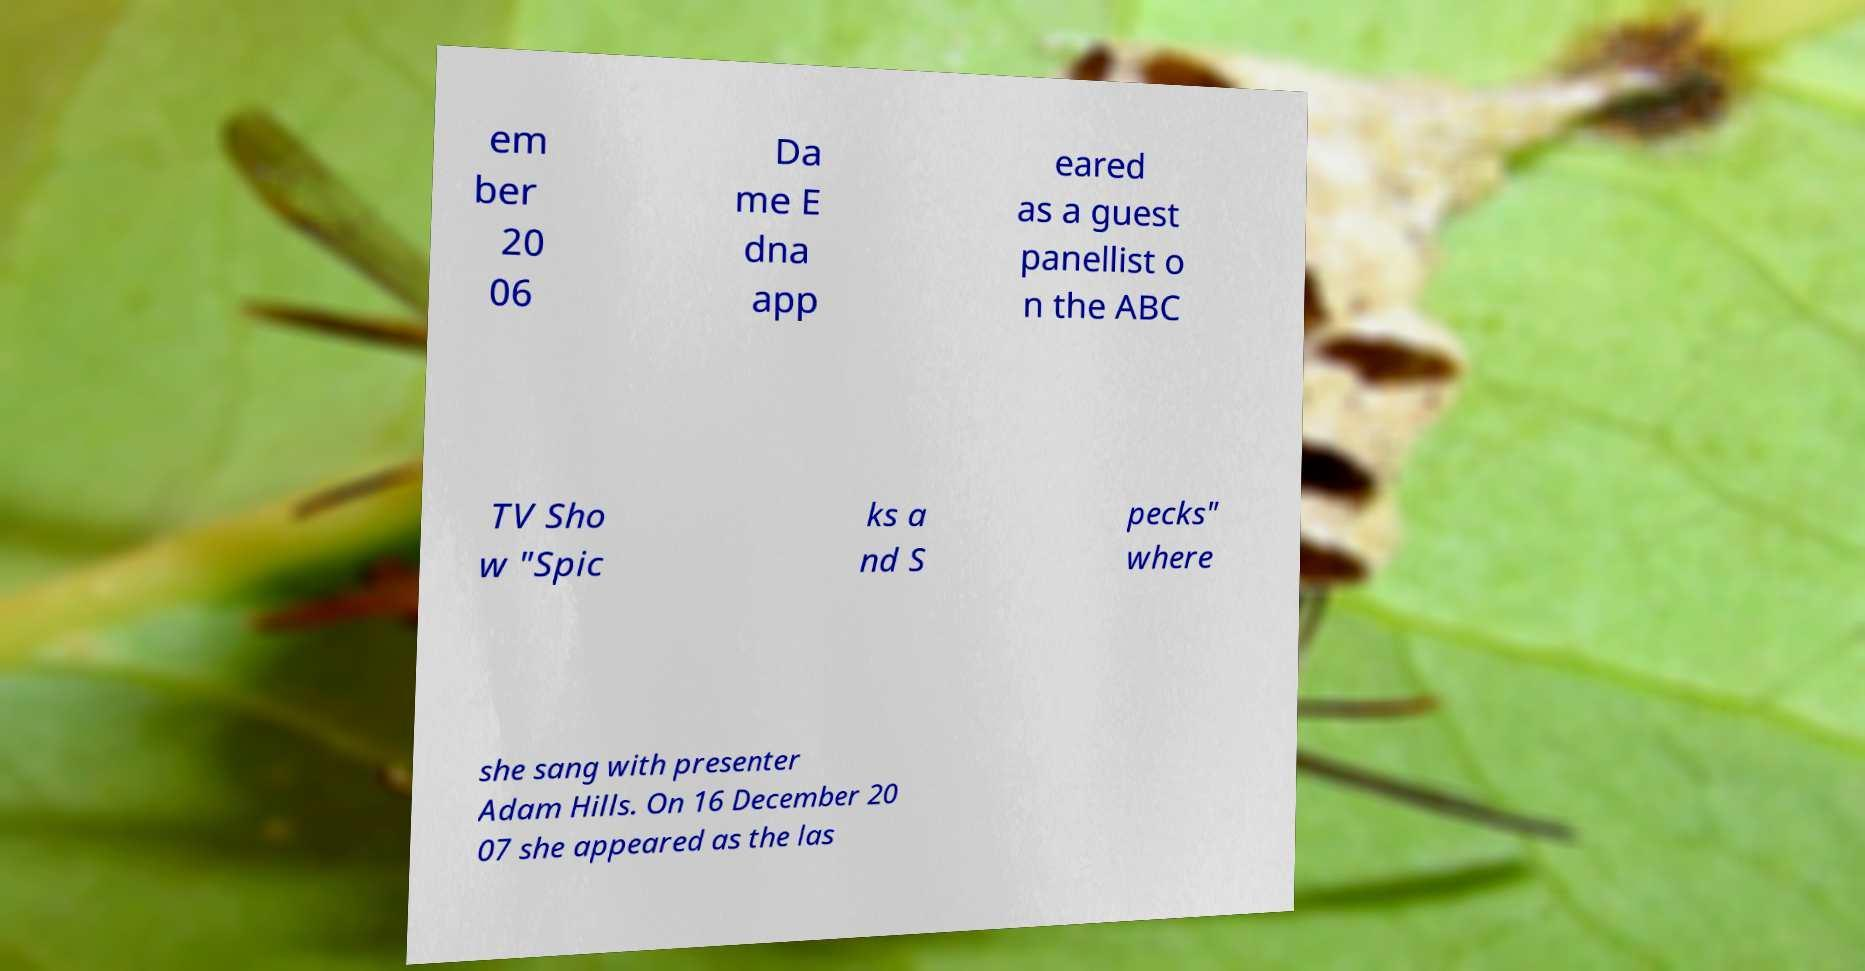Could you extract and type out the text from this image? em ber 20 06 Da me E dna app eared as a guest panellist o n the ABC TV Sho w "Spic ks a nd S pecks" where she sang with presenter Adam Hills. On 16 December 20 07 she appeared as the las 